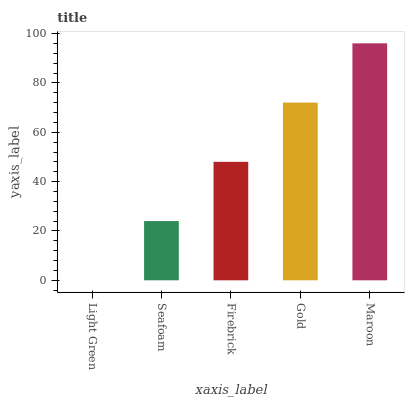Is Light Green the minimum?
Answer yes or no. Yes. Is Maroon the maximum?
Answer yes or no. Yes. Is Seafoam the minimum?
Answer yes or no. No. Is Seafoam the maximum?
Answer yes or no. No. Is Seafoam greater than Light Green?
Answer yes or no. Yes. Is Light Green less than Seafoam?
Answer yes or no. Yes. Is Light Green greater than Seafoam?
Answer yes or no. No. Is Seafoam less than Light Green?
Answer yes or no. No. Is Firebrick the high median?
Answer yes or no. Yes. Is Firebrick the low median?
Answer yes or no. Yes. Is Light Green the high median?
Answer yes or no. No. Is Light Green the low median?
Answer yes or no. No. 